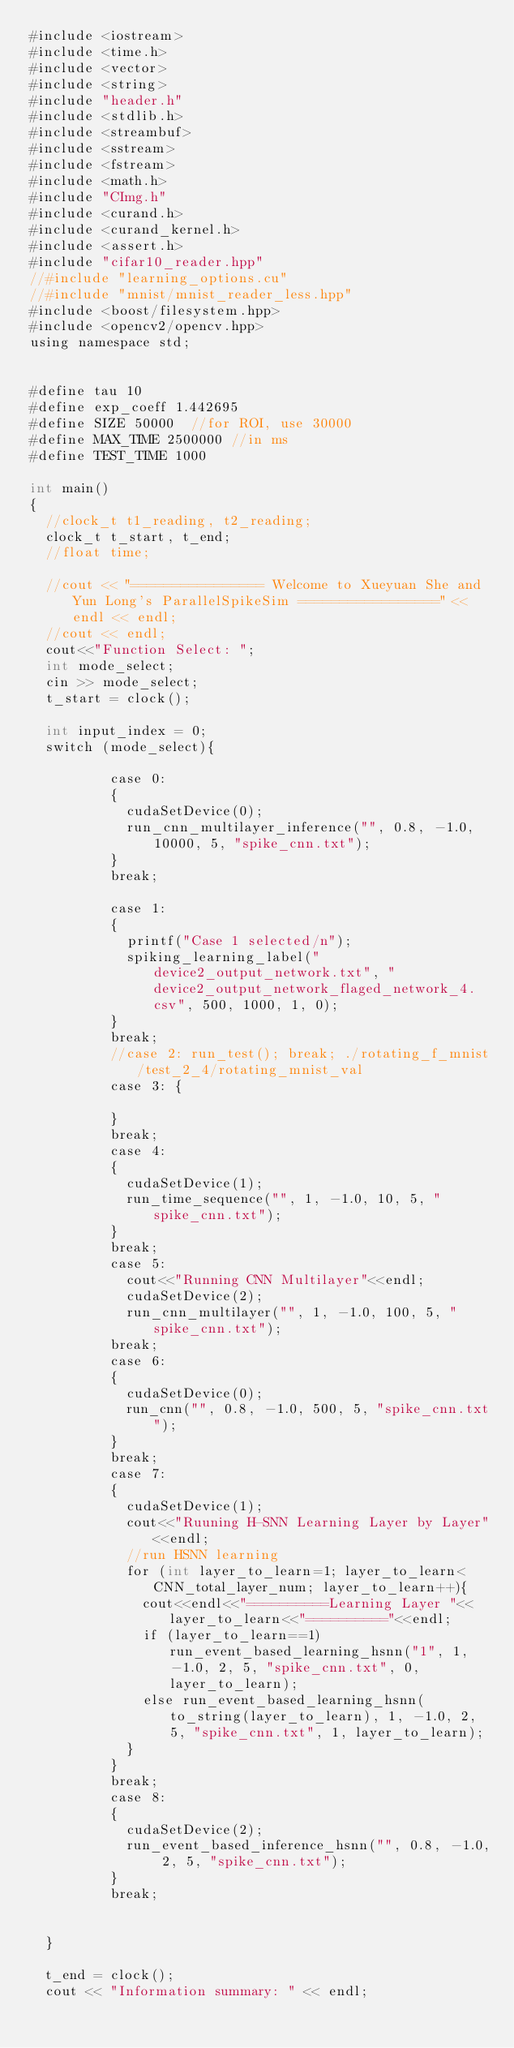Convert code to text. <code><loc_0><loc_0><loc_500><loc_500><_Cuda_>#include <iostream>
#include <time.h>
#include <vector>
#include <string>
#include "header.h"
#include <stdlib.h>
#include <streambuf>
#include <sstream>
#include <fstream>
#include <math.h>
#include "CImg.h"
#include <curand.h>
#include <curand_kernel.h>
#include <assert.h>
#include "cifar10_reader.hpp"
//#include "learning_options.cu"
//#include "mnist/mnist_reader_less.hpp"
#include <boost/filesystem.hpp>
#include <opencv2/opencv.hpp>
using namespace std;


#define tau 10
#define exp_coeff 1.442695
#define SIZE 50000  //for ROI, use 30000
#define MAX_TIME 2500000 //in ms
#define TEST_TIME 1000

int main()
{
	//clock_t t1_reading, t2_reading;
	clock_t t_start, t_end;
	//float time;

	//cout << "================ Welcome to Xueyuan She and Yun Long's ParallelSpikeSim =================" << endl << endl;
	//cout << endl;
	cout<<"Function Select: ";
	int mode_select;
	cin >> mode_select;
	t_start = clock();

	int input_index = 0;
	switch (mode_select){

					case 0:
					{
						cudaSetDevice(0);
						run_cnn_multilayer_inference("", 0.8, -1.0, 10000, 5, "spike_cnn.txt");
					}
					break;

					case 1:
					{
						printf("Case 1 selected/n");
						spiking_learning_label("device2_output_network.txt", "device2_output_network_flaged_network_4.csv", 500, 1000, 1, 0);
					}
					break;
					//case 2: run_test(); break; ./rotating_f_mnist/test_2_4/rotating_mnist_val
					case 3: {

					}
					break;
					case 4:
					{
						cudaSetDevice(1);
						run_time_sequence("", 1, -1.0, 10, 5, "spike_cnn.txt");
					}
					break;
					case 5:
						cout<<"Running CNN Multilayer"<<endl;
						cudaSetDevice(2);
						run_cnn_multilayer("", 1, -1.0, 100, 5, "spike_cnn.txt");
					break;
					case 6:
					{
						cudaSetDevice(0);
						run_cnn("", 0.8, -1.0, 500, 5, "spike_cnn.txt");
					}
					break;
					case 7:
					{
						cudaSetDevice(1);
						cout<<"Ruuning H-SNN Learning Layer by Layer"<<endl;
						//run HSNN learning
						for (int layer_to_learn=1; layer_to_learn<CNN_total_layer_num; layer_to_learn++){
							cout<<endl<<"==========Learning Layer "<<layer_to_learn<<"=========="<<endl;
							if (layer_to_learn==1) run_event_based_learning_hsnn("1", 1, -1.0, 2, 5, "spike_cnn.txt", 0, layer_to_learn);
							else run_event_based_learning_hsnn(to_string(layer_to_learn), 1, -1.0, 2, 5, "spike_cnn.txt", 1, layer_to_learn);
						}
					}
					break;
					case 8:
					{
						cudaSetDevice(2);
						run_event_based_inference_hsnn("", 0.8, -1.0, 2, 5, "spike_cnn.txt");
					}
					break;


	}

	t_end = clock();
	cout << "Information summary: " << endl;
</code> 